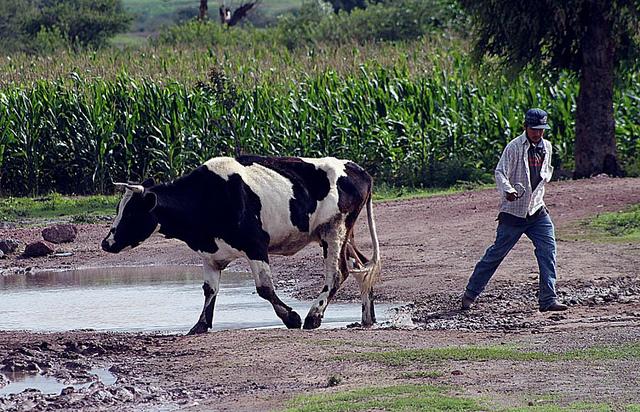Does the cow look clean or dirty?
Write a very short answer. Clean. What is the cow doing?
Write a very short answer. Walking. What animal is near the man?
Answer briefly. Cow. What is the man wearing on his head?
Concise answer only. Hat. What is growing in the background?
Give a very brief answer. Corn. 